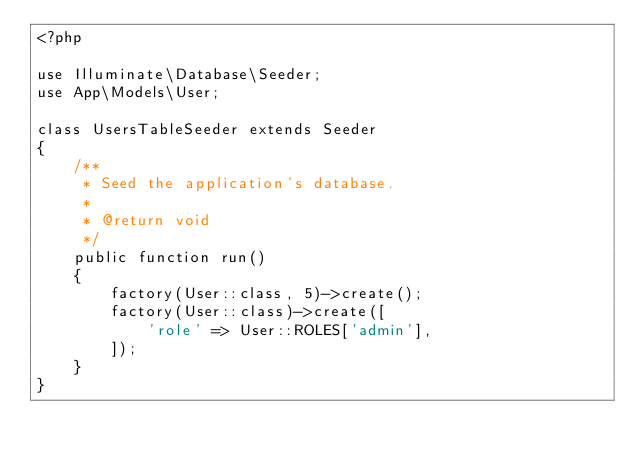Convert code to text. <code><loc_0><loc_0><loc_500><loc_500><_PHP_><?php

use Illuminate\Database\Seeder;
use App\Models\User;

class UsersTableSeeder extends Seeder
{
    /**
     * Seed the application's database.
     *
     * @return void
     */
    public function run()
    {
        factory(User::class, 5)->create();
        factory(User::class)->create([
            'role' => User::ROLES['admin'],
        ]);
    }
}
</code> 